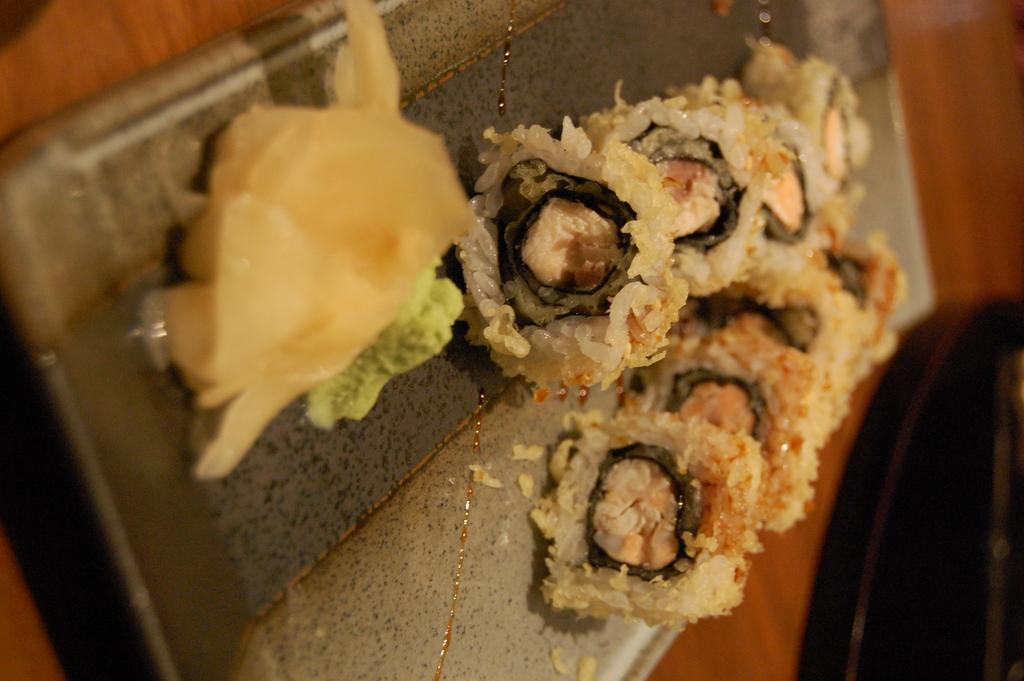What is the main piece of furniture in the image? There is a table in the image. What is placed on the table? There is a chopping board on the table. What type of food can be seen on the chopping board? There are sushi rolls on the chopping board. What type of discovery can be seen in the image? There is no discovery present in the image; it features a table with a chopping board and sushi rolls. What type of milk is being used to prepare the sushi rolls in the image? There is no milk present in the image, as sushi rolls are typically made with rice, seaweed, and various fillings. 